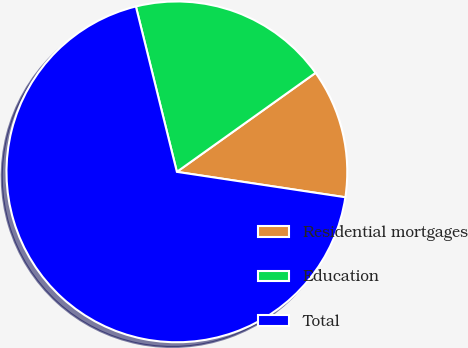Convert chart to OTSL. <chart><loc_0><loc_0><loc_500><loc_500><pie_chart><fcel>Residential mortgages<fcel>Education<fcel>Total<nl><fcel>12.25%<fcel>19.0%<fcel>68.75%<nl></chart> 